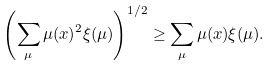<formula> <loc_0><loc_0><loc_500><loc_500>\left ( \sum _ { \mu } \mu ( x ) ^ { 2 } \xi ( \mu ) \right ) ^ { 1 / 2 } \geq \sum _ { \mu } \mu ( x ) \xi ( \mu ) .</formula> 